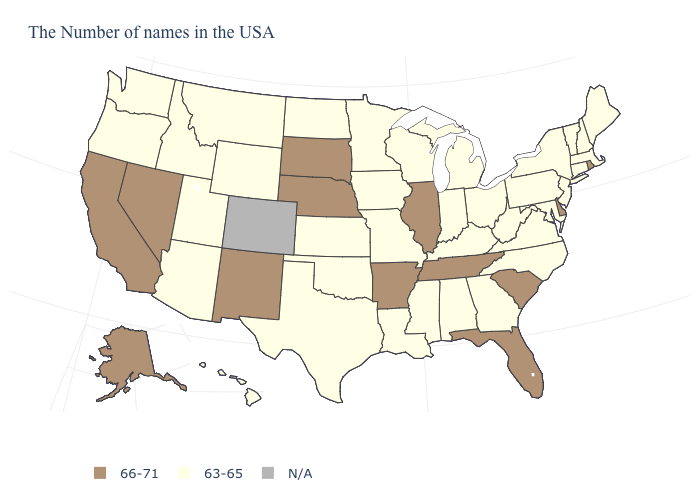Name the states that have a value in the range 66-71?
Concise answer only. Rhode Island, Delaware, South Carolina, Florida, Tennessee, Illinois, Arkansas, Nebraska, South Dakota, New Mexico, Nevada, California, Alaska. What is the value of Kentucky?
Give a very brief answer. 63-65. What is the value of Minnesota?
Concise answer only. 63-65. Name the states that have a value in the range 63-65?
Answer briefly. Maine, Massachusetts, New Hampshire, Vermont, Connecticut, New York, New Jersey, Maryland, Pennsylvania, Virginia, North Carolina, West Virginia, Ohio, Georgia, Michigan, Kentucky, Indiana, Alabama, Wisconsin, Mississippi, Louisiana, Missouri, Minnesota, Iowa, Kansas, Oklahoma, Texas, North Dakota, Wyoming, Utah, Montana, Arizona, Idaho, Washington, Oregon, Hawaii. Among the states that border Texas , does New Mexico have the highest value?
Be succinct. Yes. Among the states that border Connecticut , which have the lowest value?
Quick response, please. Massachusetts, New York. Among the states that border Minnesota , which have the lowest value?
Write a very short answer. Wisconsin, Iowa, North Dakota. Which states have the highest value in the USA?
Keep it brief. Rhode Island, Delaware, South Carolina, Florida, Tennessee, Illinois, Arkansas, Nebraska, South Dakota, New Mexico, Nevada, California, Alaska. What is the value of Virginia?
Be succinct. 63-65. What is the lowest value in the South?
Write a very short answer. 63-65. What is the value of Rhode Island?
Short answer required. 66-71. What is the highest value in states that border Utah?
Keep it brief. 66-71. Name the states that have a value in the range 66-71?
Short answer required. Rhode Island, Delaware, South Carolina, Florida, Tennessee, Illinois, Arkansas, Nebraska, South Dakota, New Mexico, Nevada, California, Alaska. Does Alaska have the highest value in the West?
Concise answer only. Yes. Does the first symbol in the legend represent the smallest category?
Write a very short answer. No. 